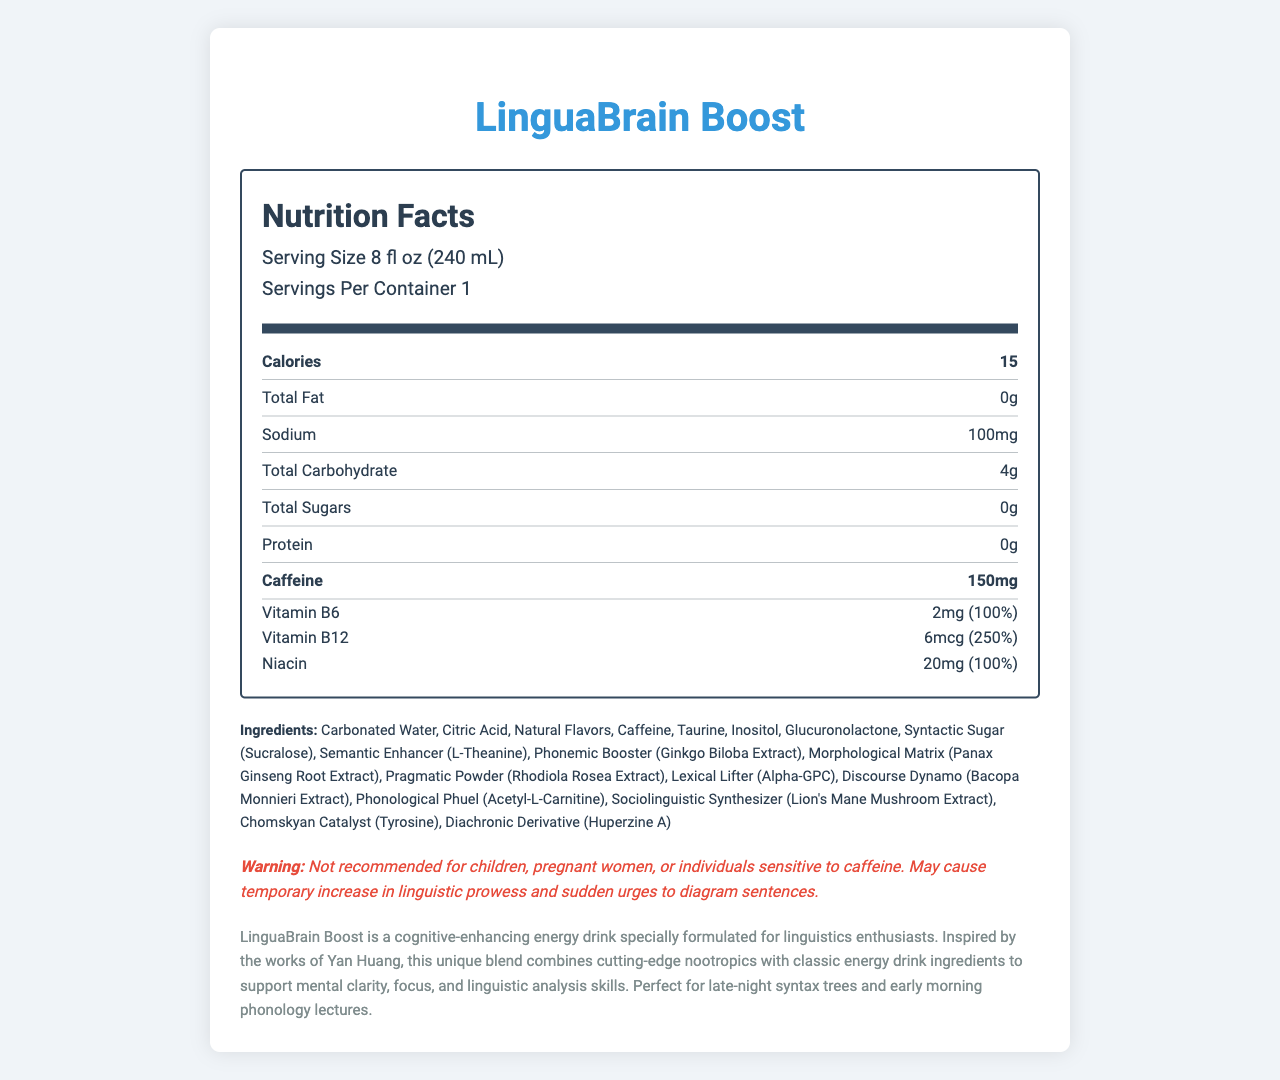what is the serving size of LinguaBrain Boost? The serving size is listed as 8 fl oz (240 mL) in the nutritional information section.
Answer: 8 fl oz (240 mL) how many calories are in one serving? The caloric content is clearly mentioned as 15 calories per serving.
Answer: 15 name two vitamins or minerals present in LinguaBrain Boost and their daily values. The document lists vitamins and minerals with their respective daily values, for instance, Vitamin B12 (250%) and Niacin (100%).
Answer: Vitamin B12 (250%) and Niacin (100%) which ingredient is referred to as the "Syntactic Sugar" in the list? The ingredient list includes "Syntactic Sugar (Sucralose)" making Sucralose the correct answer.
Answer: Sucralose what is the amount of caffeine in one serving? The nutrient section specifies that one serving contains 150mg of caffeine.
Answer: 150mg which of the following ingredients is not found in LinguaBrain Boost? A. Alpha-GPC B. Ginkgo Biloba Extract C. Green Tea Extract D. Taurine Green Tea Extract is not listed among the ingredients.
Answer: C what percent daily value of Vitamin B6 is provided by one serving? A. 100% B. 25% C. 50% D. 75% The vitamin/mineral section clearly states that Vitamin B6 provides 100% of the daily value per serving.
Answer: A is this product recommended for children? Yes/No The warning section specifically mentions that the product is not recommended for children.
Answer: No summarize the main idea of the document. The product description outlines the key purpose and unique formulation targeted at improving cognitive and linguistic abilities, reflecting its inspiration and audience.
Answer: LinguaBrain Boost is a cognitive-enhancing energy drink designed for linguistics enthusiasts. It provides mental clarity, focus, and linguistic skills support with ingredients including vitamins, caffeine, and unique nootropics named after linguistic terminology. what is the main purpose of the "Phonological Phuel" ingredient? The document lists ingredients with unique names but does not explicitly describe the purpose or effects of each ingredient such as "Phonological Phuel (Acetyl-L-Carnitine)".
Answer: Not enough information 